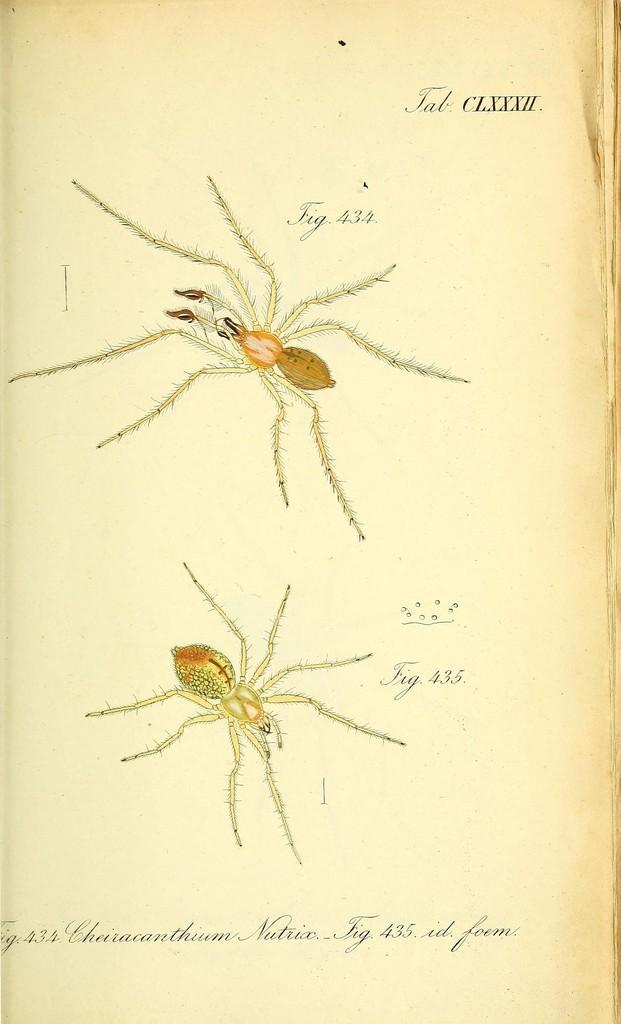Please provide a concise description of this image. It is a poster. In this image there are depictions of spiders and there is some text on the image. 